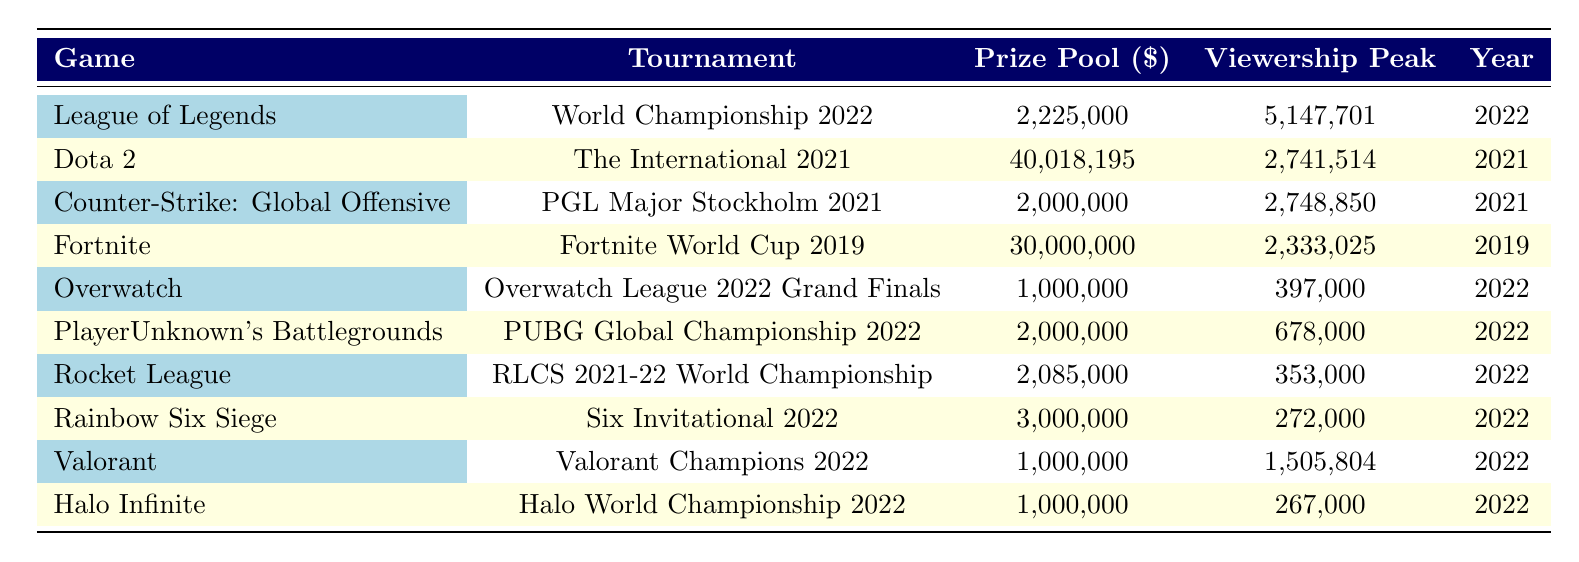What was the prize pool for the Fortnite World Cup 2019? Referring directly to the table, the prize pool for the Fortnite World Cup 2019 is listed as 30,000,000.
Answer: 30,000,000 Which game had the highest viewership peak in 2022? Checking the viewership peak column for 2022, "League of Legends" had the highest viewership peak at 5,147,701.
Answer: League of Legends What is the total prize pool of tournaments held in 2022? To find the total prize pool for 2022 tournaments, we add the prize pools: 2,225,000 + 1,000,000 + 2,000,000 + 2,085,000 + 3,000,000 + 1,000,000 + 1,000,000 = 12,310,000.
Answer: 12,310,000 Did any Dota 2 tournament appear in the year 2022? Looking at the table, there is no entry for Dota 2 tournaments in 2022. The only Dota 2 tournament listed is "The International 2021," which took place in 2021.
Answer: No What is the average prize pool for the games listed in 2021? The tournaments in 2021 are "Dota 2," "Counter-Strike: Global Offensive," which have prize pools of 40,018,195 and 2,000,000 respectively. The average prize pool is (40,018,195 + 2,000,000) / 2 = 21,009,097.5.
Answer: 21,009,097.5 Which tournament had the second highest viewership peak overall? The tournaments with the highest viewership peaks are "League of Legends" (5,147,701) and "Dota 2" (2,741,514). Therefore, the second highest is "Dota 2" with 2,741,514.
Answer: Dota 2 What was the prize pool for the Overwatch League 2022 Grand Finals compared to the Valorant Champions 2022? The prize pool for the Overwatch League 2022 Grand Finals is 1,000,000, while for Valorant Champions 2022, it is also 1,000,000. Thus, they are equal.
Answer: Equal How many games had viewership peaks over 1,000,000? Looking at the viewership peak column, there are three games with peaks over 1,000,000: "League of Legends," "Dota 2," and "Valorant." Therefore, the count is three.
Answer: 3 